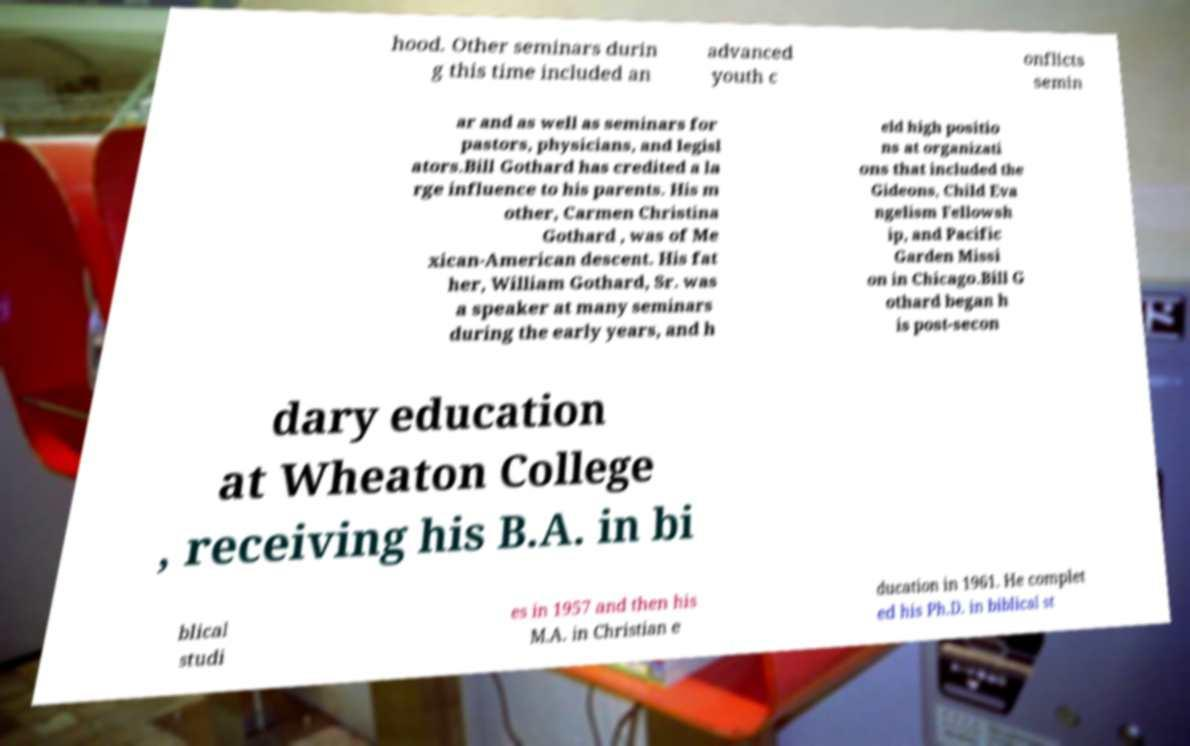For documentation purposes, I need the text within this image transcribed. Could you provide that? hood. Other seminars durin g this time included an advanced youth c onflicts semin ar and as well as seminars for pastors, physicians, and legisl ators.Bill Gothard has credited a la rge influence to his parents. His m other, Carmen Christina Gothard , was of Me xican-American descent. His fat her, William Gothard, Sr. was a speaker at many seminars during the early years, and h eld high positio ns at organizati ons that included the Gideons, Child Eva ngelism Fellowsh ip, and Pacific Garden Missi on in Chicago.Bill G othard began h is post-secon dary education at Wheaton College , receiving his B.A. in bi blical studi es in 1957 and then his M.A. in Christian e ducation in 1961. He complet ed his Ph.D. in biblical st 